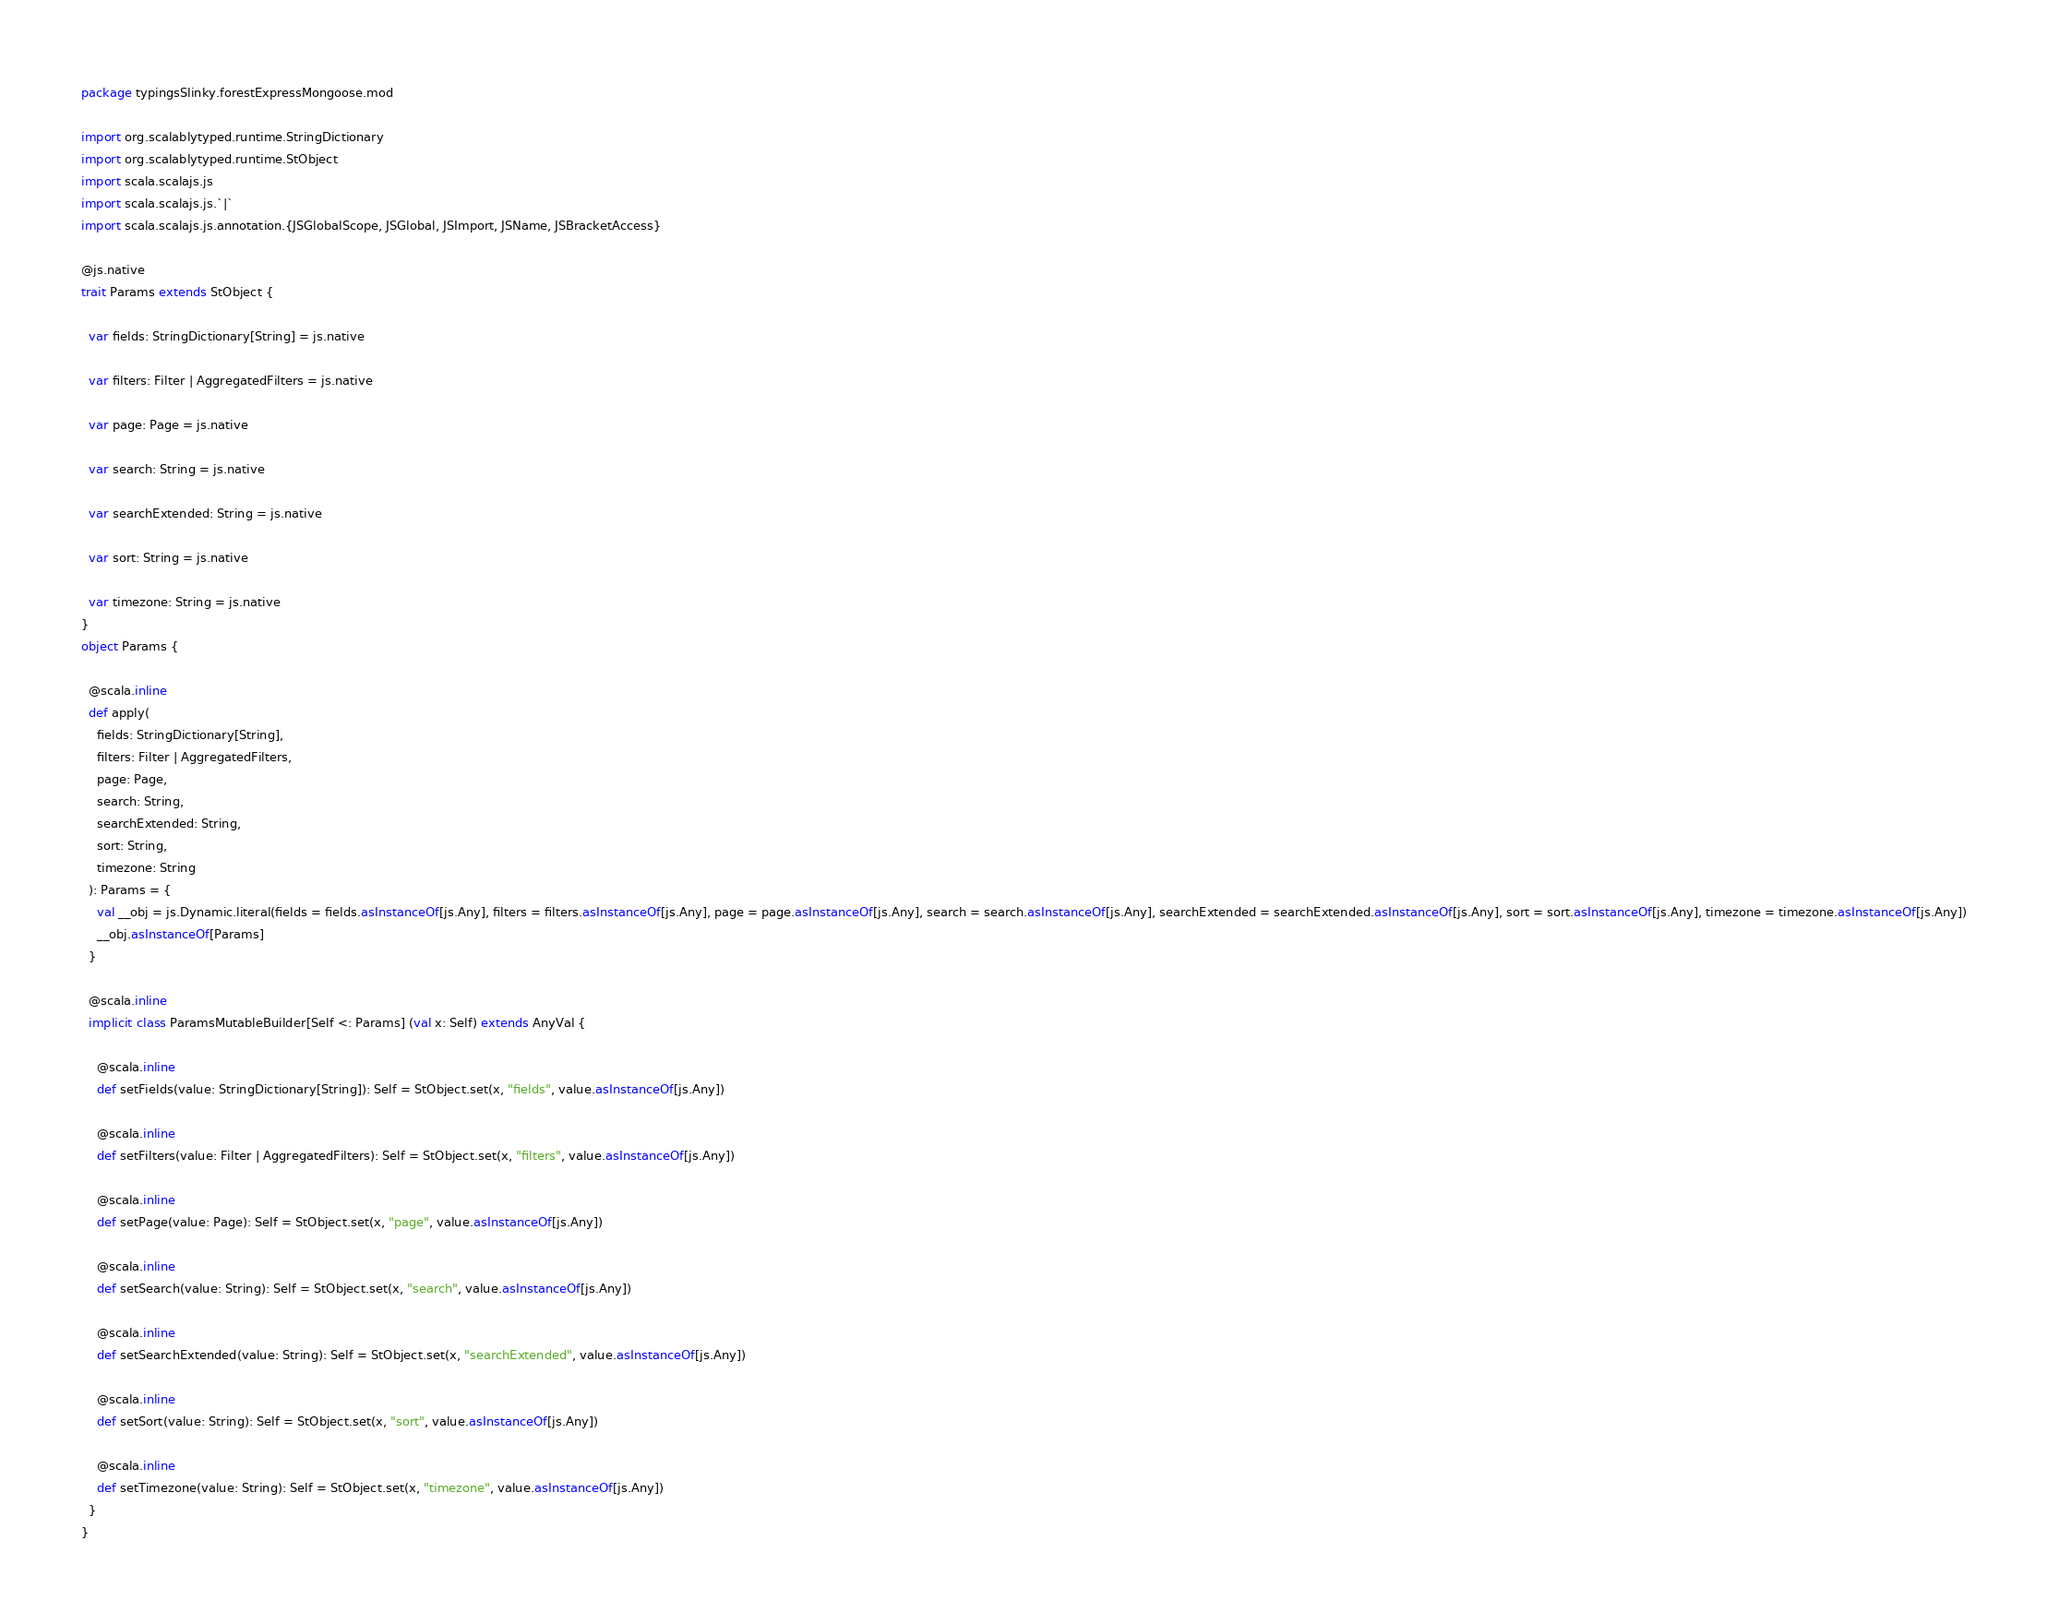Convert code to text. <code><loc_0><loc_0><loc_500><loc_500><_Scala_>package typingsSlinky.forestExpressMongoose.mod

import org.scalablytyped.runtime.StringDictionary
import org.scalablytyped.runtime.StObject
import scala.scalajs.js
import scala.scalajs.js.`|`
import scala.scalajs.js.annotation.{JSGlobalScope, JSGlobal, JSImport, JSName, JSBracketAccess}

@js.native
trait Params extends StObject {
  
  var fields: StringDictionary[String] = js.native
  
  var filters: Filter | AggregatedFilters = js.native
  
  var page: Page = js.native
  
  var search: String = js.native
  
  var searchExtended: String = js.native
  
  var sort: String = js.native
  
  var timezone: String = js.native
}
object Params {
  
  @scala.inline
  def apply(
    fields: StringDictionary[String],
    filters: Filter | AggregatedFilters,
    page: Page,
    search: String,
    searchExtended: String,
    sort: String,
    timezone: String
  ): Params = {
    val __obj = js.Dynamic.literal(fields = fields.asInstanceOf[js.Any], filters = filters.asInstanceOf[js.Any], page = page.asInstanceOf[js.Any], search = search.asInstanceOf[js.Any], searchExtended = searchExtended.asInstanceOf[js.Any], sort = sort.asInstanceOf[js.Any], timezone = timezone.asInstanceOf[js.Any])
    __obj.asInstanceOf[Params]
  }
  
  @scala.inline
  implicit class ParamsMutableBuilder[Self <: Params] (val x: Self) extends AnyVal {
    
    @scala.inline
    def setFields(value: StringDictionary[String]): Self = StObject.set(x, "fields", value.asInstanceOf[js.Any])
    
    @scala.inline
    def setFilters(value: Filter | AggregatedFilters): Self = StObject.set(x, "filters", value.asInstanceOf[js.Any])
    
    @scala.inline
    def setPage(value: Page): Self = StObject.set(x, "page", value.asInstanceOf[js.Any])
    
    @scala.inline
    def setSearch(value: String): Self = StObject.set(x, "search", value.asInstanceOf[js.Any])
    
    @scala.inline
    def setSearchExtended(value: String): Self = StObject.set(x, "searchExtended", value.asInstanceOf[js.Any])
    
    @scala.inline
    def setSort(value: String): Self = StObject.set(x, "sort", value.asInstanceOf[js.Any])
    
    @scala.inline
    def setTimezone(value: String): Self = StObject.set(x, "timezone", value.asInstanceOf[js.Any])
  }
}
</code> 